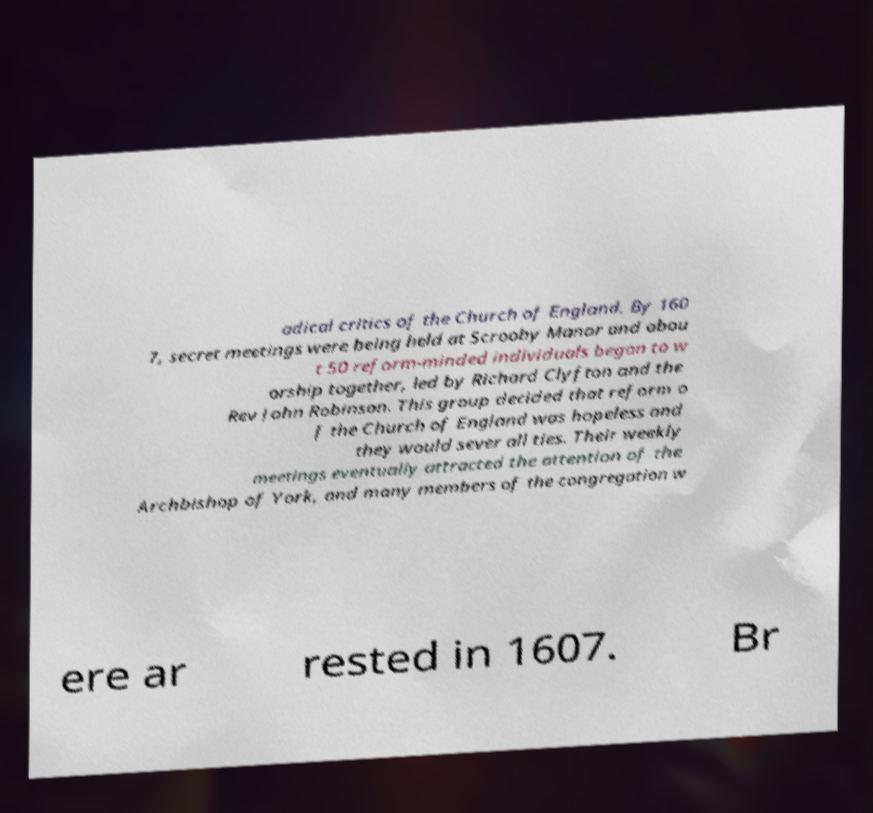What messages or text are displayed in this image? I need them in a readable, typed format. adical critics of the Church of England. By 160 7, secret meetings were being held at Scrooby Manor and abou t 50 reform-minded individuals began to w orship together, led by Richard Clyfton and the Rev John Robinson. This group decided that reform o f the Church of England was hopeless and they would sever all ties. Their weekly meetings eventually attracted the attention of the Archbishop of York, and many members of the congregation w ere ar rested in 1607. Br 